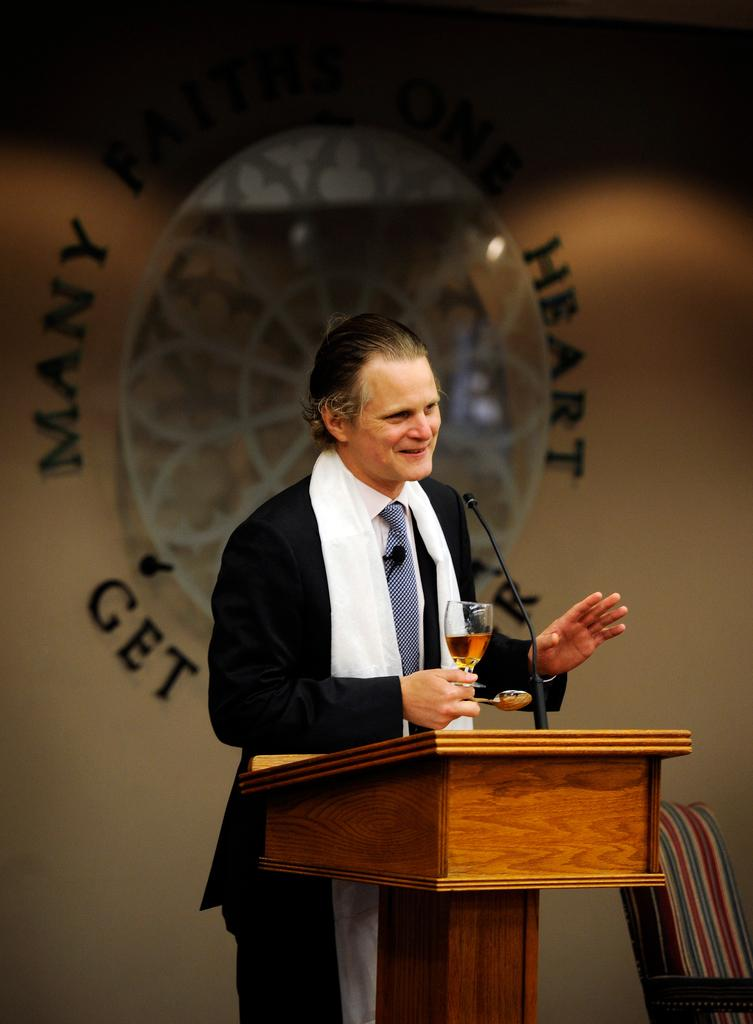What is the man in the image doing? The man is speaking at a podium in the image. What is the man holding in his right hand? The man is holding a wine glass and a spoon in his right hand. Can you describe the man's position in the image? The man is standing behind a podium in the image. How does the man's debt affect his impulse to buy more wine glasses in the image? There is no information about the man's debt or impulses in the image, so we cannot answer this question. 